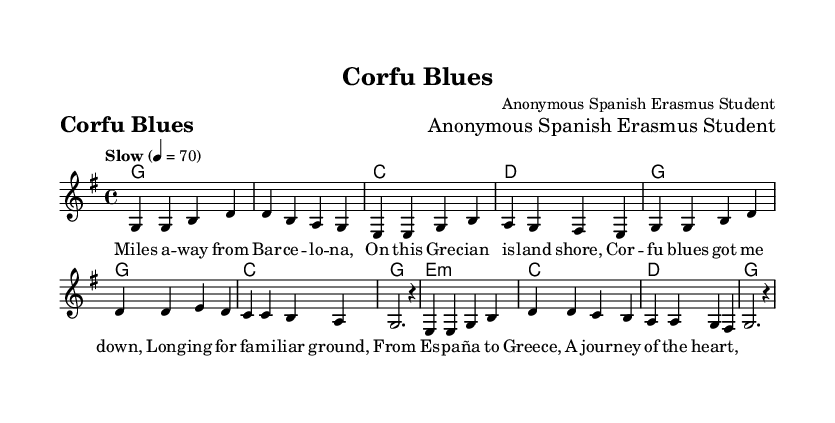What is the title of this music? The title is presented at the top of the sheet music, under the header section. It reads "Corfu Blues."
Answer: Corfu Blues What is the key signature of this music? The key signature is indicated by the key signature marker in the global section of the code. It specifies "g major," which contains one sharp.
Answer: G major What is the time signature of this music? The time signature is also found in the global section, stated as "4/4," indicating that there are four beats in a measure.
Answer: 4/4 What type of music is this? This music is associated with country, as indicated in the context of classic country ballads about long-distance relationships and homesickness.
Answer: Country How many verses are in the song? The song includes one verse as indicated by the lyrical section labeled as "verse," where only one stanza of lyrics is provided.
Answer: One What is the tempo marking of the music? The tempo marking is found in the global section where it states "Slow," followed by a metronomic indication of 70 beats per minute.
Answer: Slow What mood does the title "Corfu Blues" suggest? The title suggests a feeling of sadness and nostalgia associated with being far from home, which relates to the themes of long-distance relationships and homesickness in country ballads.
Answer: Sadness 